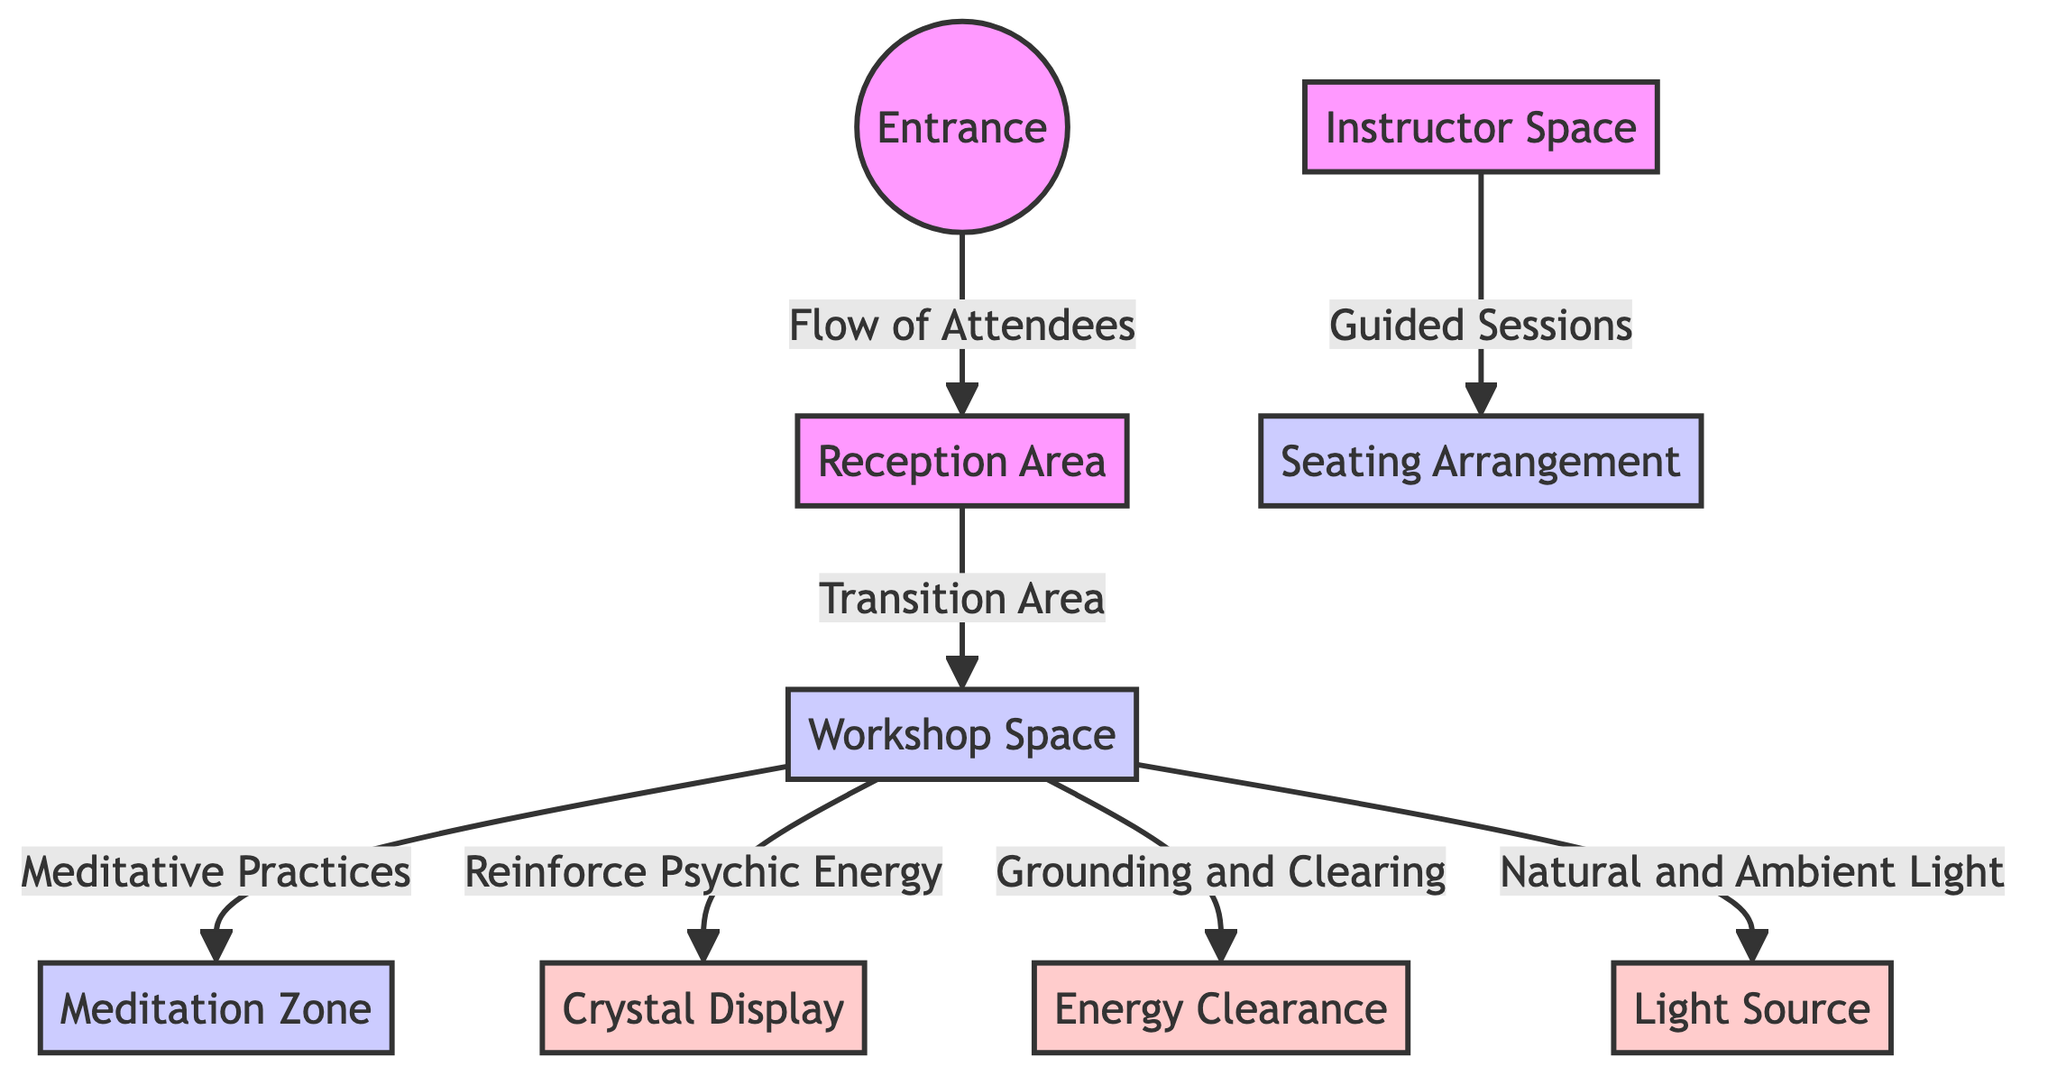What is the first node in the flow? The diagram starts with the node labeled "Entrance", indicating where attendees begin their journey into the space.
Answer: Entrance How many spaces are designated for energy? There are three spaces identified for energy: the Crystal Display, Energy Clearance, and Light Source.
Answer: 3 What type of area is the Reception Area? The Reception Area serves as a transition area, connecting the Entrance to the Workshop Space, functioning to facilitate movement and information.
Answer: Transition Area What is the main purpose of the Workshop Space? The Workshop Space is centered on meditative practices, reinforcing psychic energy, and includes provisions for grounding and clearing.
Answer: Meditative Practices Which area relates to guided sessions? The Instructor Space is explicitly noted for guided sessions that interact with the Seating Arrangement, indicating where participants engage with the instructor.
Answer: Instructor Space Which node connects the Workshop Space to the Meditation Zone? The Workshop Space directly flows into the Meditation Zone, illustrating the pathway for attendees focusing on meditation practices.
Answer: Meditation Zone What role does the Light Source play in the Workshop Space? The Light Source contributes to the natural and ambient lighting within the Workshop Space, enhancing the overall atmosphere for activities.
Answer: Natural and Ambient Light What demonstrates the flow of attendees in the diagram? The arrows connecting the Entrance to the Reception Area illustrate the flow of attendees, showing the direction of movement within the space.
Answer: Flow of Attendees How many connections does the Workshop Space have? The Workshop Space has four connections: one to the Meditation Zone, one to the Crystal Display, one to the Energy Clearance, and one to the Light Source.
Answer: 4 What does the Energy Clearance focus on? The Energy Clearance focuses on grounding and clearing energy, which supports the overall psychic vibration within the Workshop Space.
Answer: Grounding and Clearing 